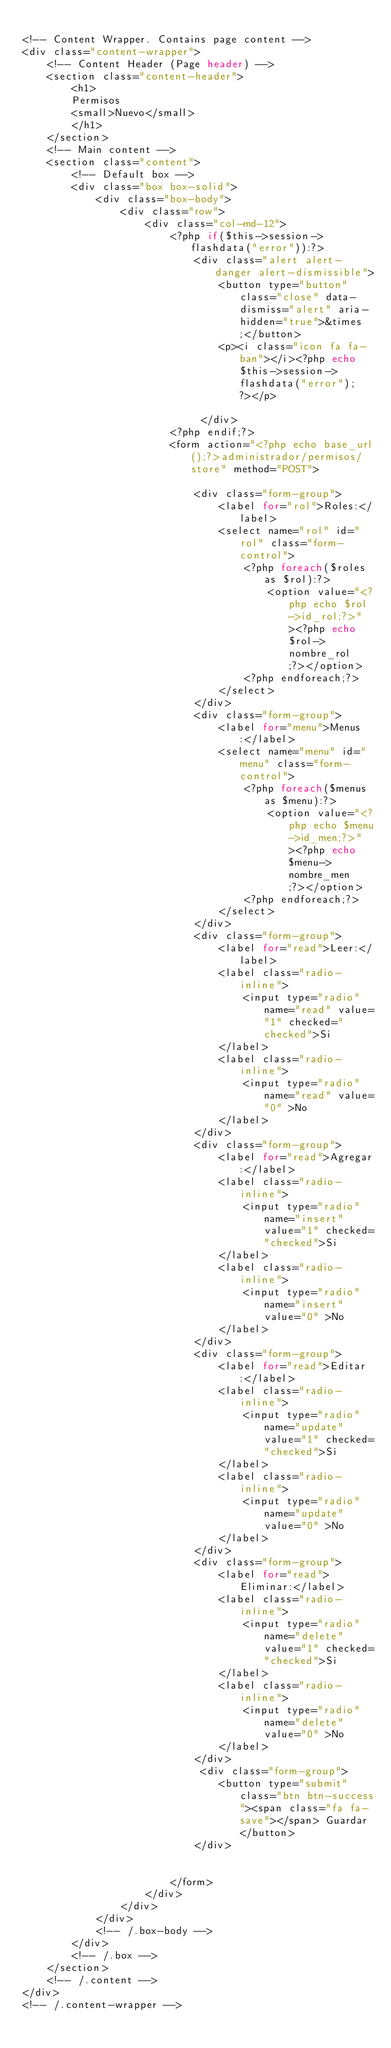Convert code to text. <code><loc_0><loc_0><loc_500><loc_500><_PHP_>
<!-- Content Wrapper. Contains page content -->
<div class="content-wrapper">
    <!-- Content Header (Page header) -->
    <section class="content-header">
        <h1>
        Permisos
        <small>Nuevo</small>
        </h1>
    </section>
    <!-- Main content -->
    <section class="content">
        <!-- Default box -->
        <div class="box box-solid">
            <div class="box-body">
                <div class="row">
                    <div class="col-md-12">
                        <?php if($this->session->flashdata("error")):?>
                            <div class="alert alert-danger alert-dismissible">
                                <button type="button" class="close" data-dismiss="alert" aria-hidden="true">&times;</button>
                                <p><i class="icon fa fa-ban"></i><?php echo $this->session->flashdata("error"); ?></p>
                                
                             </div>
                        <?php endif;?>
                        <form action="<?php echo base_url();?>administrador/permisos/store" method="POST">
                                                       
                            <div class="form-group">
                                <label for="rol">Roles:</label>
                                <select name="rol" id="rol" class="form-control">
                                    <?php foreach($roles as $rol):?>
                                        <option value="<?php echo $rol->id_rol;?>"><?php echo $rol->nombre_rol;?></option>
                                    <?php endforeach;?>
                                </select>
                            </div>
                            <div class="form-group">
                                <label for="menu">Menus:</label>
                                <select name="menu" id="menu" class="form-control">
                                    <?php foreach($menus as $menu):?>
                                        <option value="<?php echo $menu->id_men;?>"><?php echo $menu->nombre_men;?></option>
                                    <?php endforeach;?>
                                </select>
                            </div>
                            <div class="form-group">
                                <label for="read">Leer:</label>
                                <label class="radio-inline">
                                    <input type="radio" name="read" value="1" checked="checked">Si
                                </label>
                                <label class="radio-inline">
                                    <input type="radio" name="read" value="0" >No
                                </label>
                            </div>
                            <div class="form-group">
                                <label for="read">Agregar:</label>
                                <label class="radio-inline">
                                    <input type="radio" name="insert" value="1" checked="checked">Si
                                </label>
                                <label class="radio-inline">
                                    <input type="radio" name="insert" value="0" >No
                                </label>
                            </div>
                            <div class="form-group">
                                <label for="read">Editar:</label>
                                <label class="radio-inline">
                                    <input type="radio" name="update" value="1" checked="checked">Si
                                </label>
                                <label class="radio-inline">
                                    <input type="radio" name="update" value="0" >No
                                </label>
                            </div>
                            <div class="form-group">
                                <label for="read">Eliminar:</label>
                                <label class="radio-inline">
                                    <input type="radio" name="delete" value="1" checked="checked">Si
                                </label>
                                <label class="radio-inline">
                                    <input type="radio" name="delete" value="0" >No
                                </label>
                            </div>
                             <div class="form-group">
                                <button type="submit" class="btn btn-success"><span class="fa fa-save"></span> Guardar</button>
                            </div>
                            
                            
                        </form>
                    </div>
                </div>
            </div>
            <!-- /.box-body -->
        </div>
        <!-- /.box -->
    </section>
    <!-- /.content -->
</div>
<!-- /.content-wrapper -->
</code> 